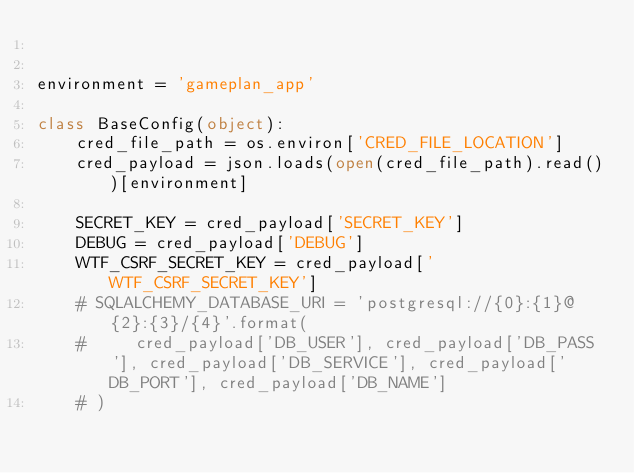<code> <loc_0><loc_0><loc_500><loc_500><_Python_>

environment = 'gameplan_app'

class BaseConfig(object):
    cred_file_path = os.environ['CRED_FILE_LOCATION']
    cred_payload = json.loads(open(cred_file_path).read())[environment]

    SECRET_KEY = cred_payload['SECRET_KEY']
    DEBUG = cred_payload['DEBUG']
    WTF_CSRF_SECRET_KEY = cred_payload['WTF_CSRF_SECRET_KEY']
    # SQLALCHEMY_DATABASE_URI = 'postgresql://{0}:{1}@{2}:{3}/{4}'.format(
    #     cred_payload['DB_USER'], cred_payload['DB_PASS'], cred_payload['DB_SERVICE'], cred_payload['DB_PORT'], cred_payload['DB_NAME']
    # )</code> 